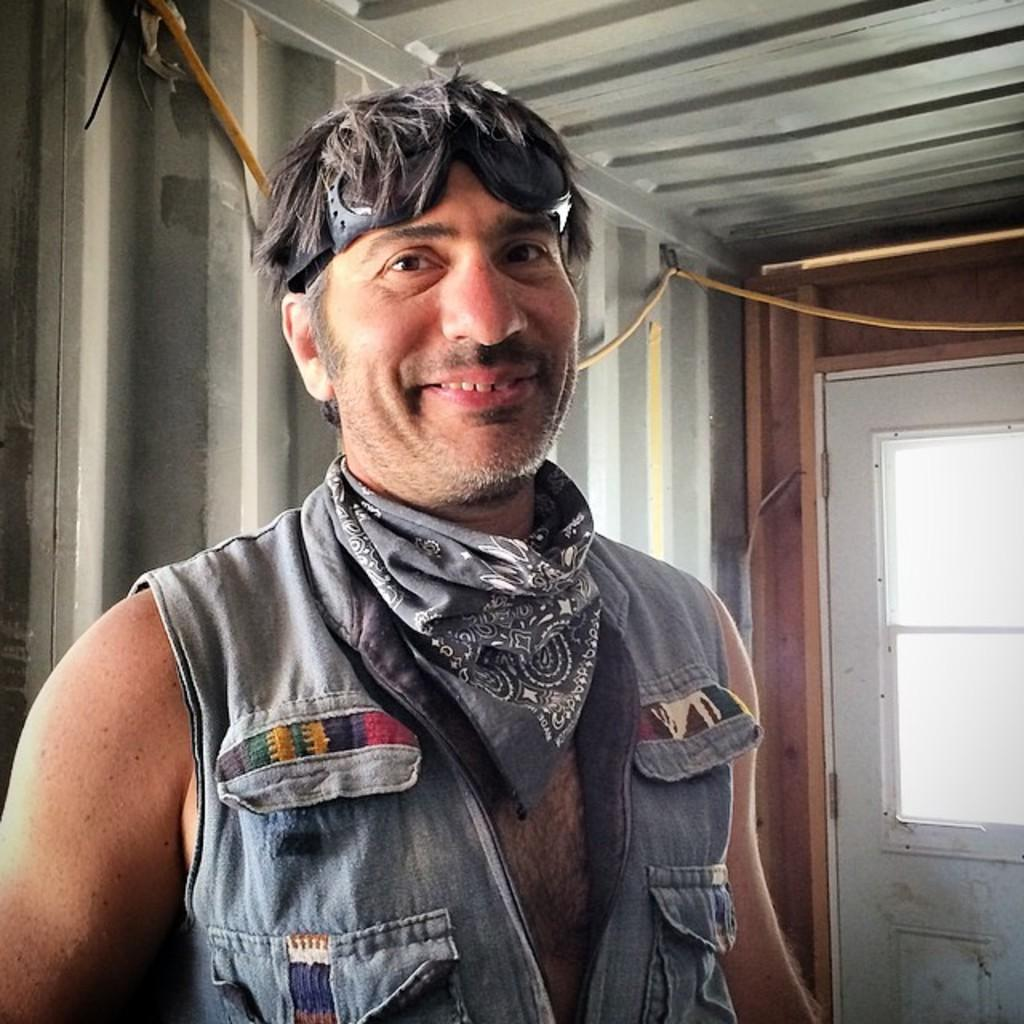Who or what is present in the image? There is a person in the image. What architectural features can be seen in the image? There are pillars in the image. What object is present that could be used for various purposes? There is a rope in the image. Where is the window located in the image? There is a window on the right side of the image. What type of maid is visible in the image? There is no maid present in the image. What angle is the goat positioned at in the image? There is no goat present in the image, so it is not possible to determine the angle at which a goat might be positioned. 